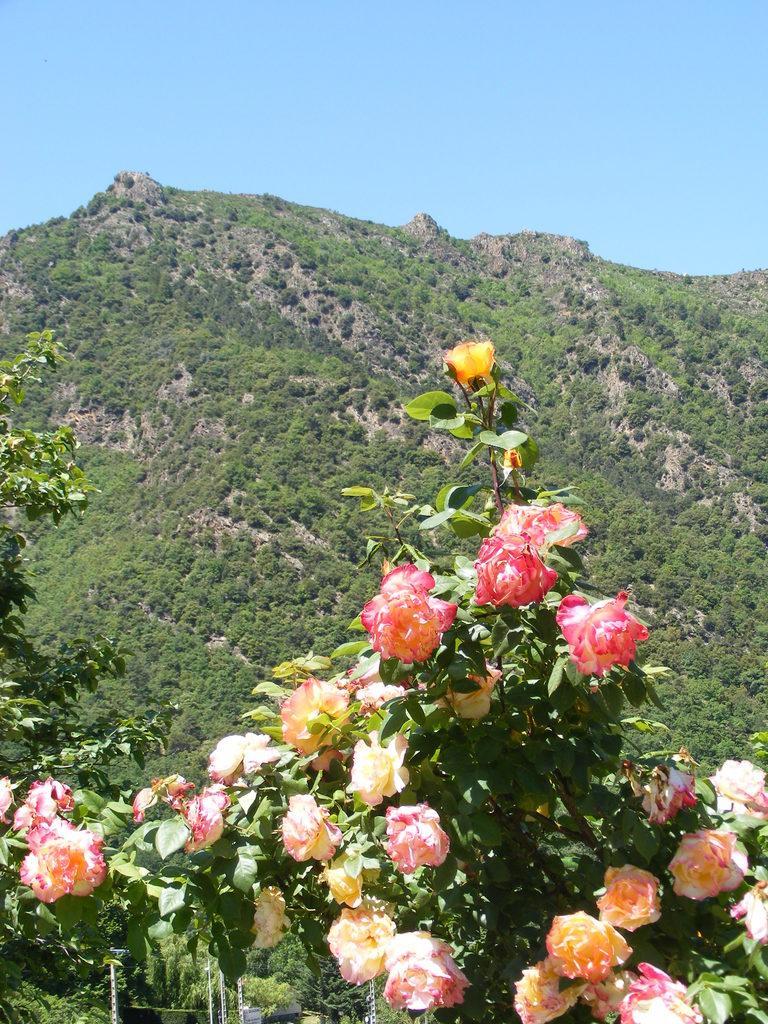Describe this image in one or two sentences. In the center of the image we can see flowers and trees. In the background we can see hills, trees and sky. 